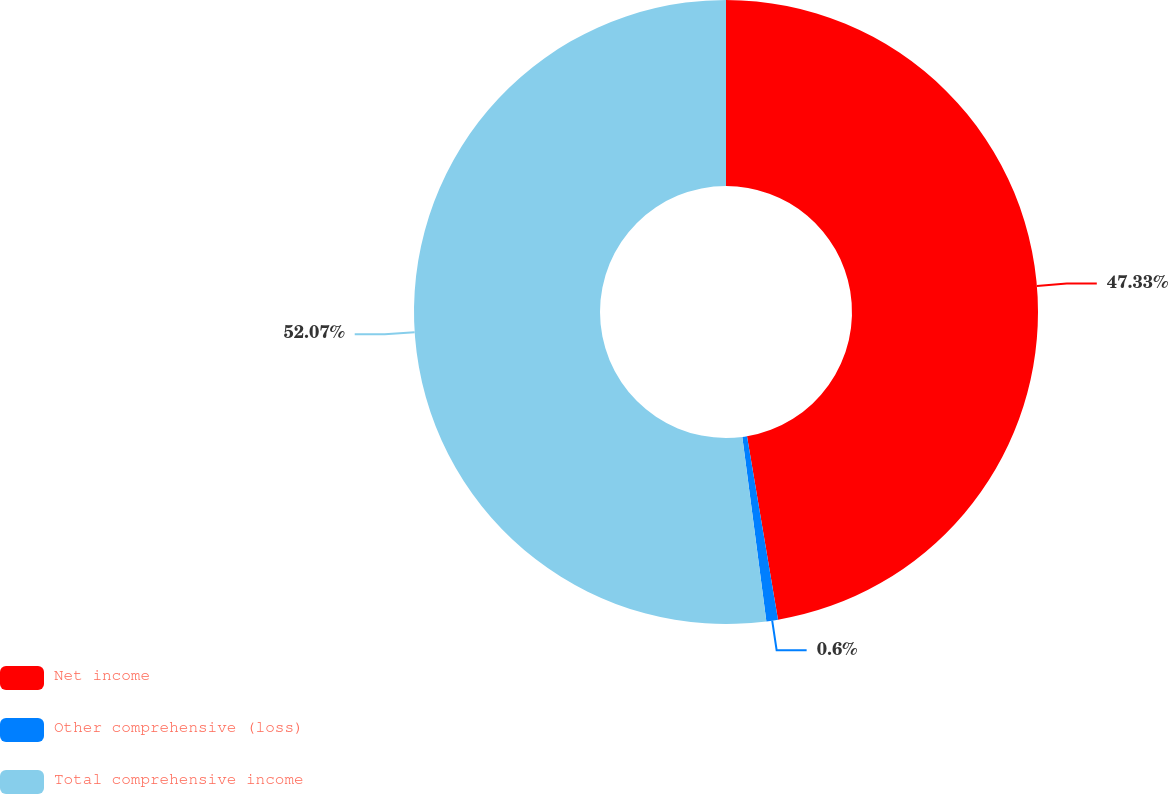Convert chart. <chart><loc_0><loc_0><loc_500><loc_500><pie_chart><fcel>Net income<fcel>Other comprehensive (loss)<fcel>Total comprehensive income<nl><fcel>47.33%<fcel>0.6%<fcel>52.06%<nl></chart> 